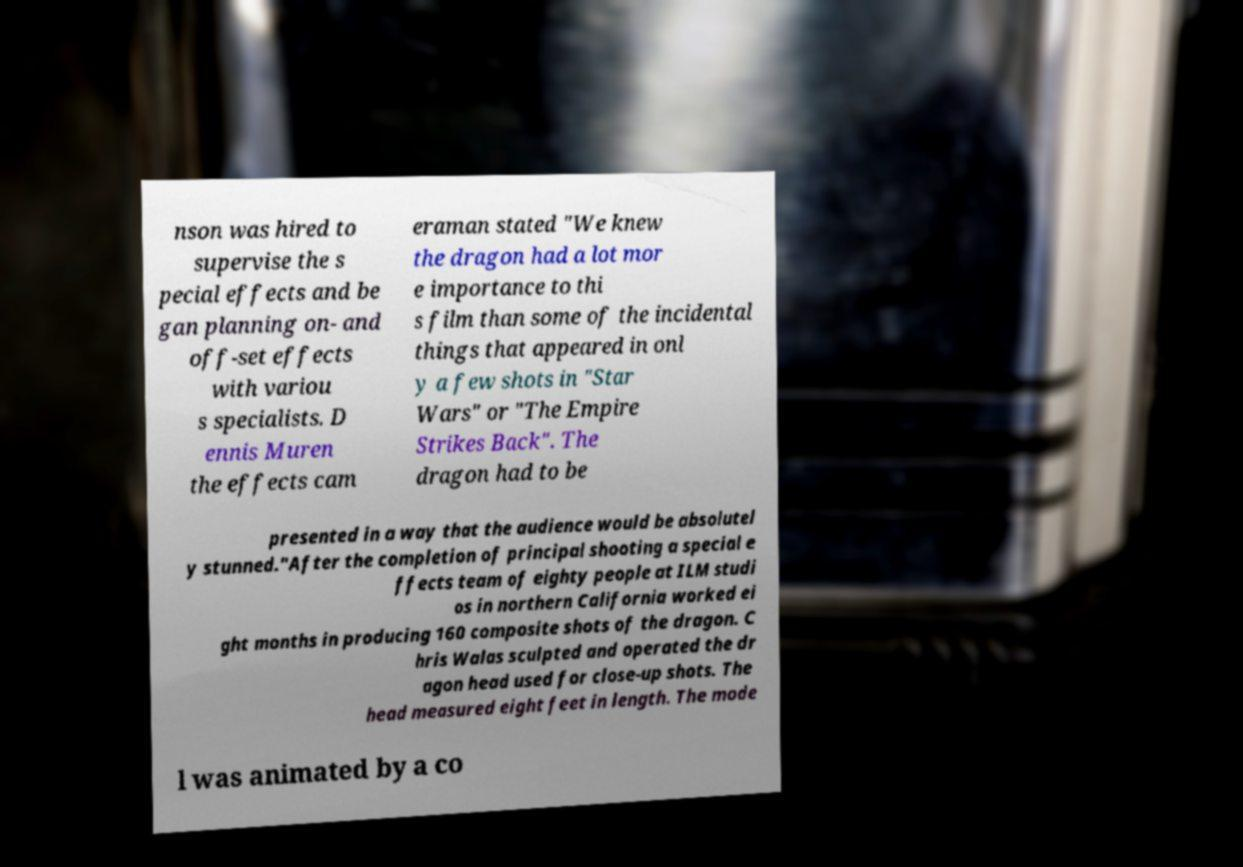Can you accurately transcribe the text from the provided image for me? nson was hired to supervise the s pecial effects and be gan planning on- and off-set effects with variou s specialists. D ennis Muren the effects cam eraman stated "We knew the dragon had a lot mor e importance to thi s film than some of the incidental things that appeared in onl y a few shots in "Star Wars" or "The Empire Strikes Back". The dragon had to be presented in a way that the audience would be absolutel y stunned."After the completion of principal shooting a special e ffects team of eighty people at ILM studi os in northern California worked ei ght months in producing 160 composite shots of the dragon. C hris Walas sculpted and operated the dr agon head used for close-up shots. The head measured eight feet in length. The mode l was animated by a co 